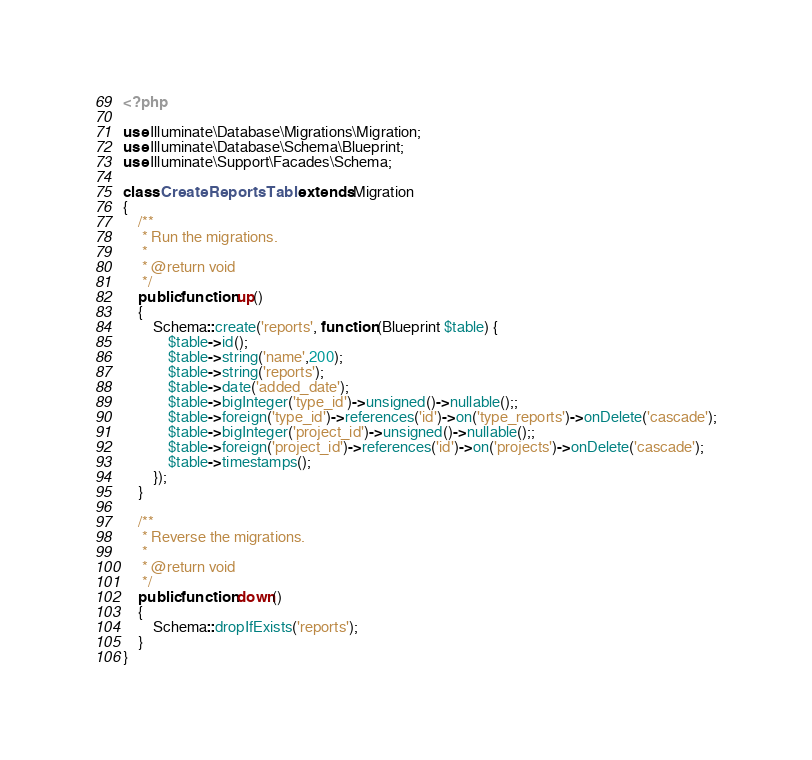<code> <loc_0><loc_0><loc_500><loc_500><_PHP_><?php

use Illuminate\Database\Migrations\Migration;
use Illuminate\Database\Schema\Blueprint;
use Illuminate\Support\Facades\Schema;

class CreateReportsTable extends Migration
{
    /**
     * Run the migrations.
     *
     * @return void
     */
    public function up()
    {
        Schema::create('reports', function (Blueprint $table) {
            $table->id();
            $table->string('name',200);
            $table->string('reports');
            $table->date('added_date');
            $table->bigInteger('type_id')->unsigned()->nullable();;
            $table->foreign('type_id')->references('id')->on('type_reports')->onDelete('cascade');
            $table->bigInteger('project_id')->unsigned()->nullable();;
            $table->foreign('project_id')->references('id')->on('projects')->onDelete('cascade');
            $table->timestamps();
        });
    }

    /**
     * Reverse the migrations.
     *
     * @return void
     */
    public function down()
    {
        Schema::dropIfExists('reports');
    }
}
</code> 